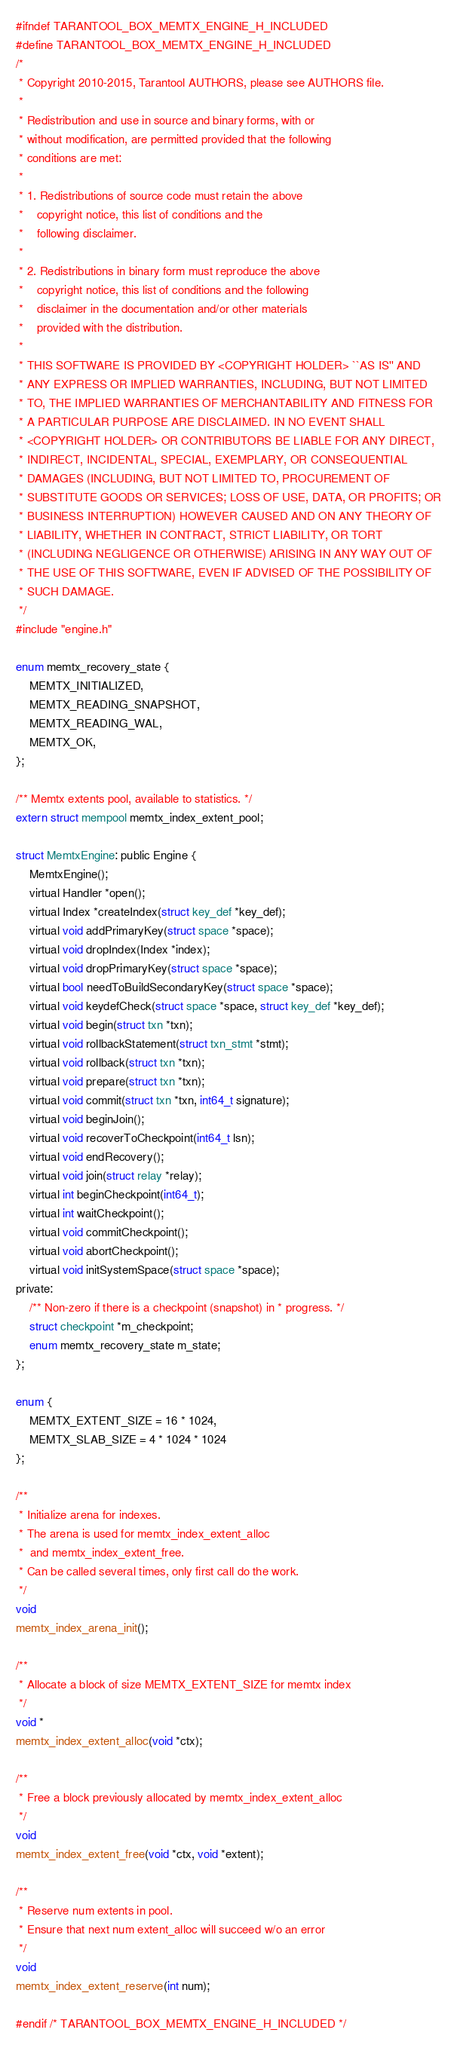Convert code to text. <code><loc_0><loc_0><loc_500><loc_500><_C_>#ifndef TARANTOOL_BOX_MEMTX_ENGINE_H_INCLUDED
#define TARANTOOL_BOX_MEMTX_ENGINE_H_INCLUDED
/*
 * Copyright 2010-2015, Tarantool AUTHORS, please see AUTHORS file.
 *
 * Redistribution and use in source and binary forms, with or
 * without modification, are permitted provided that the following
 * conditions are met:
 *
 * 1. Redistributions of source code must retain the above
 *    copyright notice, this list of conditions and the
 *    following disclaimer.
 *
 * 2. Redistributions in binary form must reproduce the above
 *    copyright notice, this list of conditions and the following
 *    disclaimer in the documentation and/or other materials
 *    provided with the distribution.
 *
 * THIS SOFTWARE IS PROVIDED BY <COPYRIGHT HOLDER> ``AS IS'' AND
 * ANY EXPRESS OR IMPLIED WARRANTIES, INCLUDING, BUT NOT LIMITED
 * TO, THE IMPLIED WARRANTIES OF MERCHANTABILITY AND FITNESS FOR
 * A PARTICULAR PURPOSE ARE DISCLAIMED. IN NO EVENT SHALL
 * <COPYRIGHT HOLDER> OR CONTRIBUTORS BE LIABLE FOR ANY DIRECT,
 * INDIRECT, INCIDENTAL, SPECIAL, EXEMPLARY, OR CONSEQUENTIAL
 * DAMAGES (INCLUDING, BUT NOT LIMITED TO, PROCUREMENT OF
 * SUBSTITUTE GOODS OR SERVICES; LOSS OF USE, DATA, OR PROFITS; OR
 * BUSINESS INTERRUPTION) HOWEVER CAUSED AND ON ANY THEORY OF
 * LIABILITY, WHETHER IN CONTRACT, STRICT LIABILITY, OR TORT
 * (INCLUDING NEGLIGENCE OR OTHERWISE) ARISING IN ANY WAY OUT OF
 * THE USE OF THIS SOFTWARE, EVEN IF ADVISED OF THE POSSIBILITY OF
 * SUCH DAMAGE.
 */
#include "engine.h"

enum memtx_recovery_state {
	MEMTX_INITIALIZED,
	MEMTX_READING_SNAPSHOT,
	MEMTX_READING_WAL,
	MEMTX_OK,
};

/** Memtx extents pool, available to statistics. */
extern struct mempool memtx_index_extent_pool;

struct MemtxEngine: public Engine {
	MemtxEngine();
	virtual Handler *open();
	virtual Index *createIndex(struct key_def *key_def);
	virtual void addPrimaryKey(struct space *space);
	virtual void dropIndex(Index *index);
	virtual void dropPrimaryKey(struct space *space);
	virtual bool needToBuildSecondaryKey(struct space *space);
	virtual void keydefCheck(struct space *space, struct key_def *key_def);
	virtual void begin(struct txn *txn);
	virtual void rollbackStatement(struct txn_stmt *stmt);
	virtual void rollback(struct txn *txn);
	virtual void prepare(struct txn *txn);
	virtual void commit(struct txn *txn, int64_t signature);
	virtual void beginJoin();
	virtual void recoverToCheckpoint(int64_t lsn);
	virtual void endRecovery();
	virtual void join(struct relay *relay);
	virtual int beginCheckpoint(int64_t);
	virtual int waitCheckpoint();
	virtual void commitCheckpoint();
	virtual void abortCheckpoint();
	virtual void initSystemSpace(struct space *space);
private:
	/** Non-zero if there is a checkpoint (snapshot) in * progress. */
	struct checkpoint *m_checkpoint;
	enum memtx_recovery_state m_state;
};

enum {
	MEMTX_EXTENT_SIZE = 16 * 1024,
	MEMTX_SLAB_SIZE = 4 * 1024 * 1024
};

/**
 * Initialize arena for indexes.
 * The arena is used for memtx_index_extent_alloc
 *  and memtx_index_extent_free.
 * Can be called several times, only first call do the work.
 */
void
memtx_index_arena_init();

/**
 * Allocate a block of size MEMTX_EXTENT_SIZE for memtx index
 */
void *
memtx_index_extent_alloc(void *ctx);

/**
 * Free a block previously allocated by memtx_index_extent_alloc
 */
void
memtx_index_extent_free(void *ctx, void *extent);

/**
 * Reserve num extents in pool.
 * Ensure that next num extent_alloc will succeed w/o an error
 */
void
memtx_index_extent_reserve(int num);

#endif /* TARANTOOL_BOX_MEMTX_ENGINE_H_INCLUDED */
</code> 